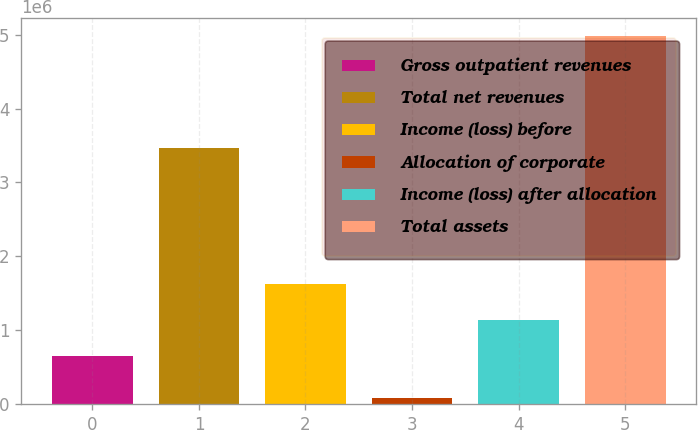Convert chart. <chart><loc_0><loc_0><loc_500><loc_500><bar_chart><fcel>Gross outpatient revenues<fcel>Total net revenues<fcel>Income (loss) before<fcel>Allocation of corporate<fcel>Income (loss) after allocation<fcel>Total assets<nl><fcel>646177<fcel>3.46014e+06<fcel>1.62525e+06<fcel>84597<fcel>1.13571e+06<fcel>4.97996e+06<nl></chart> 